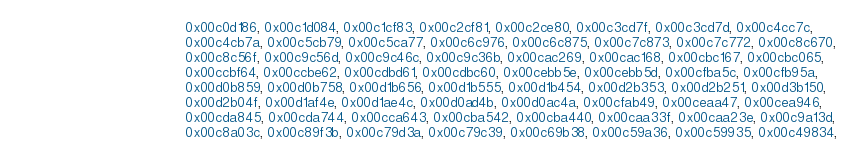Convert code to text. <code><loc_0><loc_0><loc_500><loc_500><_C_>                                        0x00c0d186, 0x00c1d084, 0x00c1cf83, 0x00c2cf81, 0x00c2ce80, 0x00c3cd7f, 0x00c3cd7d, 0x00c4cc7c, 
                                        0x00c4cb7a, 0x00c5cb79, 0x00c5ca77, 0x00c6c976, 0x00c6c875, 0x00c7c873, 0x00c7c772, 0x00c8c670, 
                                        0x00c8c56f, 0x00c9c56d, 0x00c9c46c, 0x00c9c36b, 0x00cac269, 0x00cac168, 0x00cbc167, 0x00cbc065, 
                                        0x00ccbf64, 0x00ccbe62, 0x00cdbd61, 0x00cdbc60, 0x00cebb5e, 0x00cebb5d, 0x00cfba5c, 0x00cfb95a, 
                                        0x00d0b859, 0x00d0b758, 0x00d1b656, 0x00d1b555, 0x00d1b454, 0x00d2b353, 0x00d2b251, 0x00d3b150, 
                                        0x00d2b04f, 0x00d1af4e, 0x00d1ae4c, 0x00d0ad4b, 0x00d0ac4a, 0x00cfab49, 0x00ceaa47, 0x00cea946, 
                                        0x00cda845, 0x00cda744, 0x00cca643, 0x00cba542, 0x00cba440, 0x00caa33f, 0x00caa23e, 0x00c9a13d, 
                                        0x00c8a03c, 0x00c89f3b, 0x00c79d3a, 0x00c79c39, 0x00c69b38, 0x00c59a36, 0x00c59935, 0x00c49834, </code> 